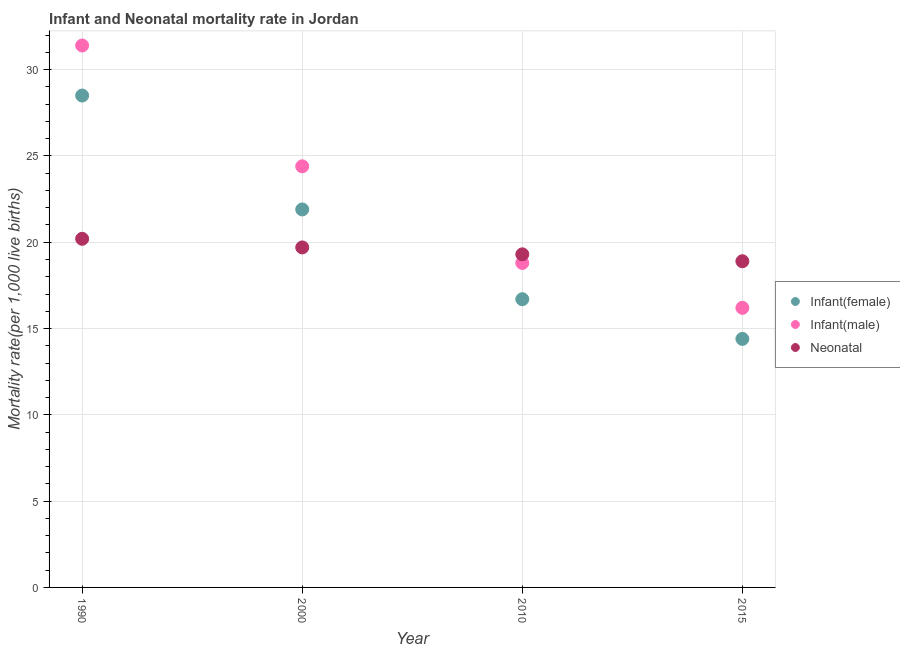How many different coloured dotlines are there?
Ensure brevity in your answer.  3. Across all years, what is the maximum neonatal mortality rate?
Offer a terse response. 20.2. Across all years, what is the minimum neonatal mortality rate?
Keep it short and to the point. 18.9. In which year was the infant mortality rate(male) maximum?
Keep it short and to the point. 1990. In which year was the neonatal mortality rate minimum?
Your answer should be very brief. 2015. What is the total neonatal mortality rate in the graph?
Make the answer very short. 78.1. What is the difference between the infant mortality rate(male) in 1990 and that in 2015?
Your answer should be compact. 15.2. What is the difference between the infant mortality rate(female) in 1990 and the infant mortality rate(male) in 2000?
Provide a short and direct response. 4.1. What is the average infant mortality rate(male) per year?
Your response must be concise. 22.7. In the year 1990, what is the difference between the infant mortality rate(male) and infant mortality rate(female)?
Offer a very short reply. 2.9. In how many years, is the neonatal mortality rate greater than 21?
Your answer should be very brief. 0. What is the ratio of the neonatal mortality rate in 2000 to that in 2015?
Offer a very short reply. 1.04. What is the difference between the highest and the second highest infant mortality rate(female)?
Offer a terse response. 6.6. What is the difference between the highest and the lowest neonatal mortality rate?
Make the answer very short. 1.3. Is it the case that in every year, the sum of the infant mortality rate(female) and infant mortality rate(male) is greater than the neonatal mortality rate?
Provide a short and direct response. Yes. Is the neonatal mortality rate strictly less than the infant mortality rate(female) over the years?
Give a very brief answer. No. How many dotlines are there?
Provide a succinct answer. 3. How many years are there in the graph?
Offer a very short reply. 4. Are the values on the major ticks of Y-axis written in scientific E-notation?
Ensure brevity in your answer.  No. Does the graph contain grids?
Your response must be concise. Yes. How many legend labels are there?
Your answer should be compact. 3. What is the title of the graph?
Provide a succinct answer. Infant and Neonatal mortality rate in Jordan. Does "Transport" appear as one of the legend labels in the graph?
Keep it short and to the point. No. What is the label or title of the Y-axis?
Provide a succinct answer. Mortality rate(per 1,0 live births). What is the Mortality rate(per 1,000 live births) in Infant(female) in 1990?
Provide a succinct answer. 28.5. What is the Mortality rate(per 1,000 live births) in Infant(male) in 1990?
Offer a very short reply. 31.4. What is the Mortality rate(per 1,000 live births) in Neonatal  in 1990?
Give a very brief answer. 20.2. What is the Mortality rate(per 1,000 live births) of Infant(female) in 2000?
Your answer should be very brief. 21.9. What is the Mortality rate(per 1,000 live births) of Infant(male) in 2000?
Provide a succinct answer. 24.4. What is the Mortality rate(per 1,000 live births) in Neonatal  in 2000?
Your answer should be compact. 19.7. What is the Mortality rate(per 1,000 live births) in Infant(female) in 2010?
Offer a terse response. 16.7. What is the Mortality rate(per 1,000 live births) in Neonatal  in 2010?
Make the answer very short. 19.3. What is the Mortality rate(per 1,000 live births) in Infant(female) in 2015?
Make the answer very short. 14.4. What is the Mortality rate(per 1,000 live births) in Infant(male) in 2015?
Make the answer very short. 16.2. Across all years, what is the maximum Mortality rate(per 1,000 live births) in Infant(female)?
Offer a terse response. 28.5. Across all years, what is the maximum Mortality rate(per 1,000 live births) in Infant(male)?
Ensure brevity in your answer.  31.4. Across all years, what is the maximum Mortality rate(per 1,000 live births) in Neonatal ?
Provide a succinct answer. 20.2. Across all years, what is the minimum Mortality rate(per 1,000 live births) in Infant(female)?
Your answer should be very brief. 14.4. What is the total Mortality rate(per 1,000 live births) of Infant(female) in the graph?
Offer a terse response. 81.5. What is the total Mortality rate(per 1,000 live births) of Infant(male) in the graph?
Your answer should be compact. 90.8. What is the total Mortality rate(per 1,000 live births) in Neonatal  in the graph?
Your response must be concise. 78.1. What is the difference between the Mortality rate(per 1,000 live births) in Neonatal  in 1990 and that in 2000?
Provide a short and direct response. 0.5. What is the difference between the Mortality rate(per 1,000 live births) of Infant(male) in 1990 and that in 2010?
Make the answer very short. 12.6. What is the difference between the Mortality rate(per 1,000 live births) of Neonatal  in 1990 and that in 2010?
Your answer should be very brief. 0.9. What is the difference between the Mortality rate(per 1,000 live births) of Infant(male) in 1990 and that in 2015?
Give a very brief answer. 15.2. What is the difference between the Mortality rate(per 1,000 live births) in Neonatal  in 2000 and that in 2010?
Your answer should be very brief. 0.4. What is the difference between the Mortality rate(per 1,000 live births) in Infant(male) in 2000 and that in 2015?
Your answer should be very brief. 8.2. What is the difference between the Mortality rate(per 1,000 live births) of Infant(female) in 2010 and that in 2015?
Ensure brevity in your answer.  2.3. What is the difference between the Mortality rate(per 1,000 live births) of Neonatal  in 2010 and that in 2015?
Your answer should be compact. 0.4. What is the difference between the Mortality rate(per 1,000 live births) of Infant(female) in 1990 and the Mortality rate(per 1,000 live births) of Neonatal  in 2000?
Provide a short and direct response. 8.8. What is the difference between the Mortality rate(per 1,000 live births) of Infant(female) in 1990 and the Mortality rate(per 1,000 live births) of Neonatal  in 2015?
Provide a succinct answer. 9.6. What is the difference between the Mortality rate(per 1,000 live births) of Infant(female) in 2000 and the Mortality rate(per 1,000 live births) of Infant(male) in 2010?
Give a very brief answer. 3.1. What is the difference between the Mortality rate(per 1,000 live births) of Infant(male) in 2000 and the Mortality rate(per 1,000 live births) of Neonatal  in 2010?
Ensure brevity in your answer.  5.1. What is the difference between the Mortality rate(per 1,000 live births) in Infant(female) in 2010 and the Mortality rate(per 1,000 live births) in Infant(male) in 2015?
Provide a short and direct response. 0.5. What is the average Mortality rate(per 1,000 live births) in Infant(female) per year?
Give a very brief answer. 20.38. What is the average Mortality rate(per 1,000 live births) in Infant(male) per year?
Offer a very short reply. 22.7. What is the average Mortality rate(per 1,000 live births) of Neonatal  per year?
Offer a very short reply. 19.52. In the year 1990, what is the difference between the Mortality rate(per 1,000 live births) in Infant(female) and Mortality rate(per 1,000 live births) in Neonatal ?
Provide a short and direct response. 8.3. In the year 2000, what is the difference between the Mortality rate(per 1,000 live births) in Infant(female) and Mortality rate(per 1,000 live births) in Infant(male)?
Make the answer very short. -2.5. In the year 2010, what is the difference between the Mortality rate(per 1,000 live births) in Infant(female) and Mortality rate(per 1,000 live births) in Neonatal ?
Offer a very short reply. -2.6. In the year 2015, what is the difference between the Mortality rate(per 1,000 live births) in Infant(female) and Mortality rate(per 1,000 live births) in Infant(male)?
Keep it short and to the point. -1.8. In the year 2015, what is the difference between the Mortality rate(per 1,000 live births) of Infant(female) and Mortality rate(per 1,000 live births) of Neonatal ?
Provide a short and direct response. -4.5. What is the ratio of the Mortality rate(per 1,000 live births) of Infant(female) in 1990 to that in 2000?
Offer a terse response. 1.3. What is the ratio of the Mortality rate(per 1,000 live births) in Infant(male) in 1990 to that in 2000?
Keep it short and to the point. 1.29. What is the ratio of the Mortality rate(per 1,000 live births) of Neonatal  in 1990 to that in 2000?
Offer a terse response. 1.03. What is the ratio of the Mortality rate(per 1,000 live births) in Infant(female) in 1990 to that in 2010?
Give a very brief answer. 1.71. What is the ratio of the Mortality rate(per 1,000 live births) of Infant(male) in 1990 to that in 2010?
Give a very brief answer. 1.67. What is the ratio of the Mortality rate(per 1,000 live births) of Neonatal  in 1990 to that in 2010?
Your answer should be very brief. 1.05. What is the ratio of the Mortality rate(per 1,000 live births) in Infant(female) in 1990 to that in 2015?
Make the answer very short. 1.98. What is the ratio of the Mortality rate(per 1,000 live births) of Infant(male) in 1990 to that in 2015?
Provide a succinct answer. 1.94. What is the ratio of the Mortality rate(per 1,000 live births) in Neonatal  in 1990 to that in 2015?
Keep it short and to the point. 1.07. What is the ratio of the Mortality rate(per 1,000 live births) of Infant(female) in 2000 to that in 2010?
Give a very brief answer. 1.31. What is the ratio of the Mortality rate(per 1,000 live births) of Infant(male) in 2000 to that in 2010?
Offer a very short reply. 1.3. What is the ratio of the Mortality rate(per 1,000 live births) in Neonatal  in 2000 to that in 2010?
Keep it short and to the point. 1.02. What is the ratio of the Mortality rate(per 1,000 live births) in Infant(female) in 2000 to that in 2015?
Offer a very short reply. 1.52. What is the ratio of the Mortality rate(per 1,000 live births) in Infant(male) in 2000 to that in 2015?
Give a very brief answer. 1.51. What is the ratio of the Mortality rate(per 1,000 live births) in Neonatal  in 2000 to that in 2015?
Offer a very short reply. 1.04. What is the ratio of the Mortality rate(per 1,000 live births) of Infant(female) in 2010 to that in 2015?
Make the answer very short. 1.16. What is the ratio of the Mortality rate(per 1,000 live births) in Infant(male) in 2010 to that in 2015?
Make the answer very short. 1.16. What is the ratio of the Mortality rate(per 1,000 live births) in Neonatal  in 2010 to that in 2015?
Your response must be concise. 1.02. What is the difference between the highest and the second highest Mortality rate(per 1,000 live births) of Infant(female)?
Provide a succinct answer. 6.6. What is the difference between the highest and the second highest Mortality rate(per 1,000 live births) of Neonatal ?
Keep it short and to the point. 0.5. What is the difference between the highest and the lowest Mortality rate(per 1,000 live births) of Infant(male)?
Your response must be concise. 15.2. What is the difference between the highest and the lowest Mortality rate(per 1,000 live births) of Neonatal ?
Offer a very short reply. 1.3. 